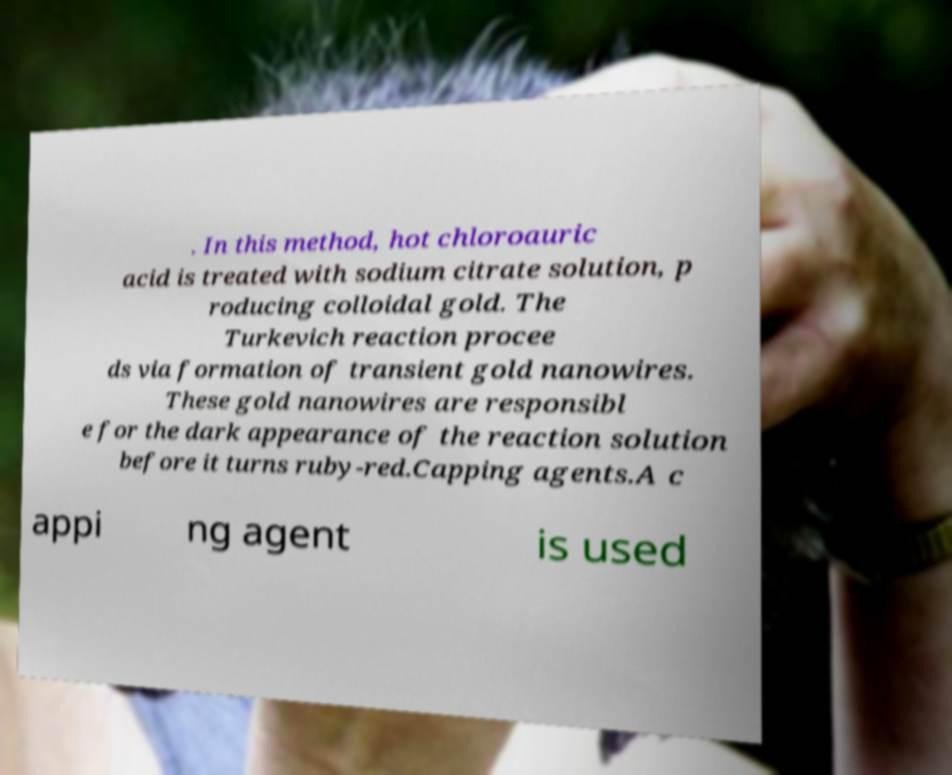Can you accurately transcribe the text from the provided image for me? . In this method, hot chloroauric acid is treated with sodium citrate solution, p roducing colloidal gold. The Turkevich reaction procee ds via formation of transient gold nanowires. These gold nanowires are responsibl e for the dark appearance of the reaction solution before it turns ruby-red.Capping agents.A c appi ng agent is used 